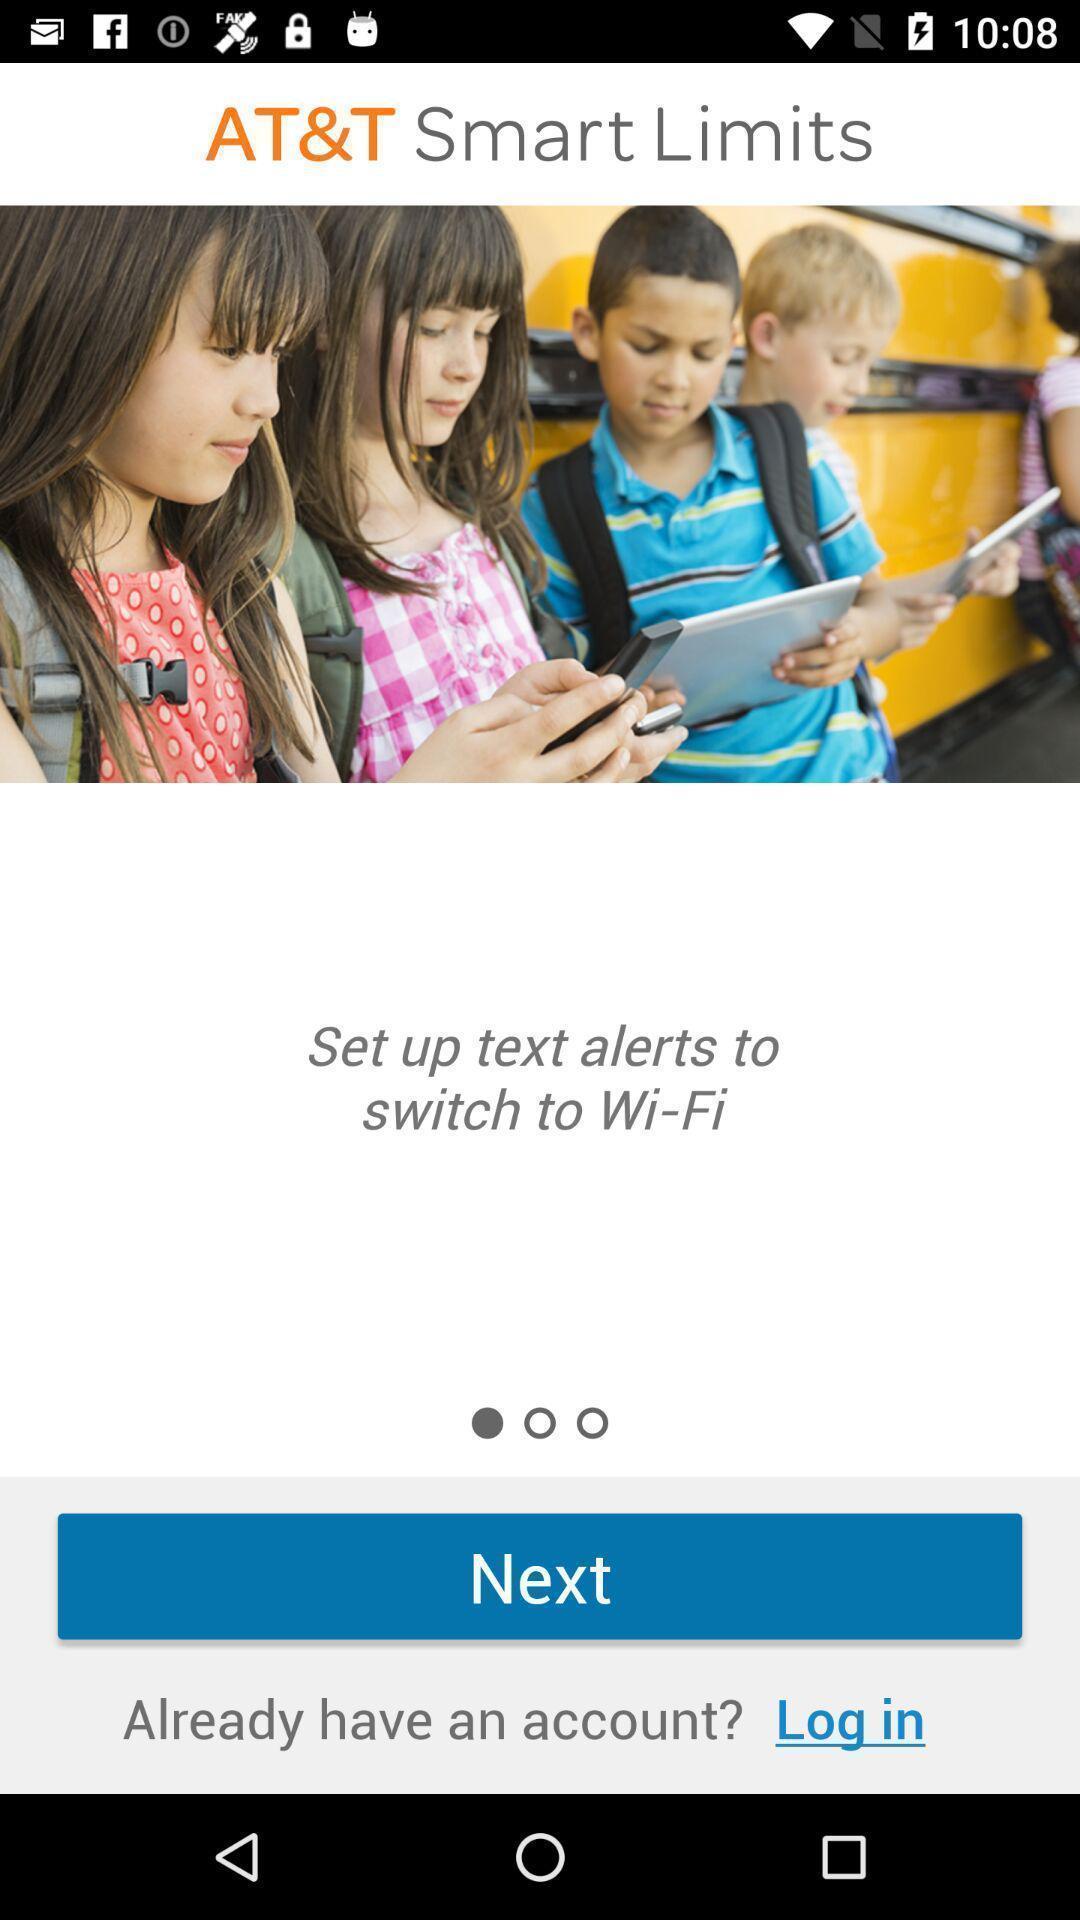Summarize the information in this screenshot. Welcome page with next option. 